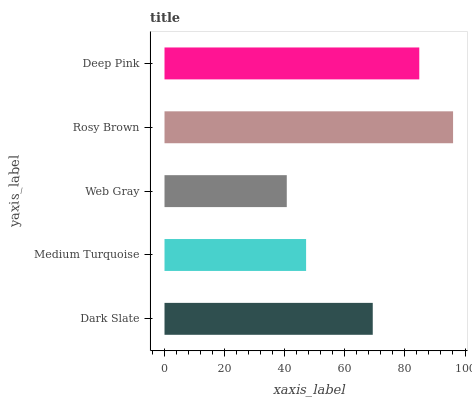Is Web Gray the minimum?
Answer yes or no. Yes. Is Rosy Brown the maximum?
Answer yes or no. Yes. Is Medium Turquoise the minimum?
Answer yes or no. No. Is Medium Turquoise the maximum?
Answer yes or no. No. Is Dark Slate greater than Medium Turquoise?
Answer yes or no. Yes. Is Medium Turquoise less than Dark Slate?
Answer yes or no. Yes. Is Medium Turquoise greater than Dark Slate?
Answer yes or no. No. Is Dark Slate less than Medium Turquoise?
Answer yes or no. No. Is Dark Slate the high median?
Answer yes or no. Yes. Is Dark Slate the low median?
Answer yes or no. Yes. Is Medium Turquoise the high median?
Answer yes or no. No. Is Rosy Brown the low median?
Answer yes or no. No. 